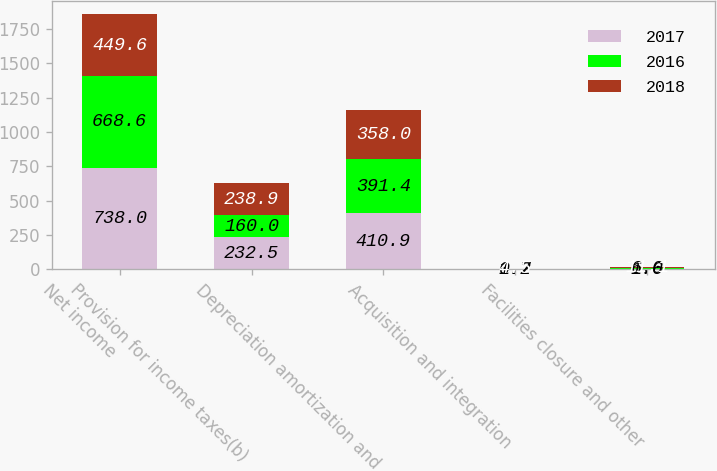Convert chart to OTSL. <chart><loc_0><loc_0><loc_500><loc_500><stacked_bar_chart><ecel><fcel>Net income<fcel>Provision for income taxes(b)<fcel>Depreciation amortization and<fcel>Acquisition and integration<fcel>Facilities closure and other<nl><fcel>2017<fcel>738<fcel>232.5<fcel>410.9<fcel>0.2<fcel>1.6<nl><fcel>2016<fcel>668.6<fcel>160<fcel>391.4<fcel>1.7<fcel>6<nl><fcel>2018<fcel>449.6<fcel>238.9<fcel>358<fcel>4.5<fcel>11.1<nl></chart> 